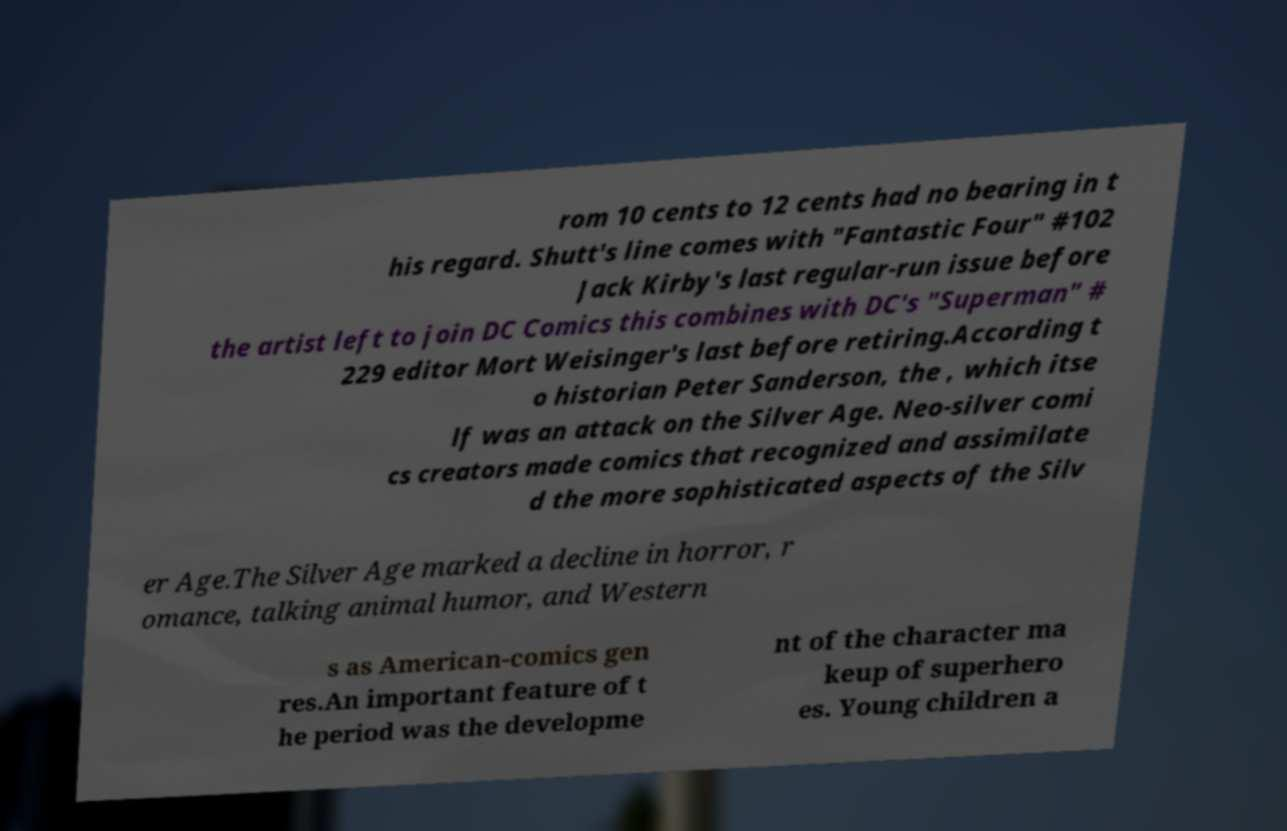There's text embedded in this image that I need extracted. Can you transcribe it verbatim? rom 10 cents to 12 cents had no bearing in t his regard. Shutt's line comes with "Fantastic Four" #102 Jack Kirby's last regular-run issue before the artist left to join DC Comics this combines with DC's "Superman" # 229 editor Mort Weisinger's last before retiring.According t o historian Peter Sanderson, the , which itse lf was an attack on the Silver Age. Neo-silver comi cs creators made comics that recognized and assimilate d the more sophisticated aspects of the Silv er Age.The Silver Age marked a decline in horror, r omance, talking animal humor, and Western s as American-comics gen res.An important feature of t he period was the developme nt of the character ma keup of superhero es. Young children a 